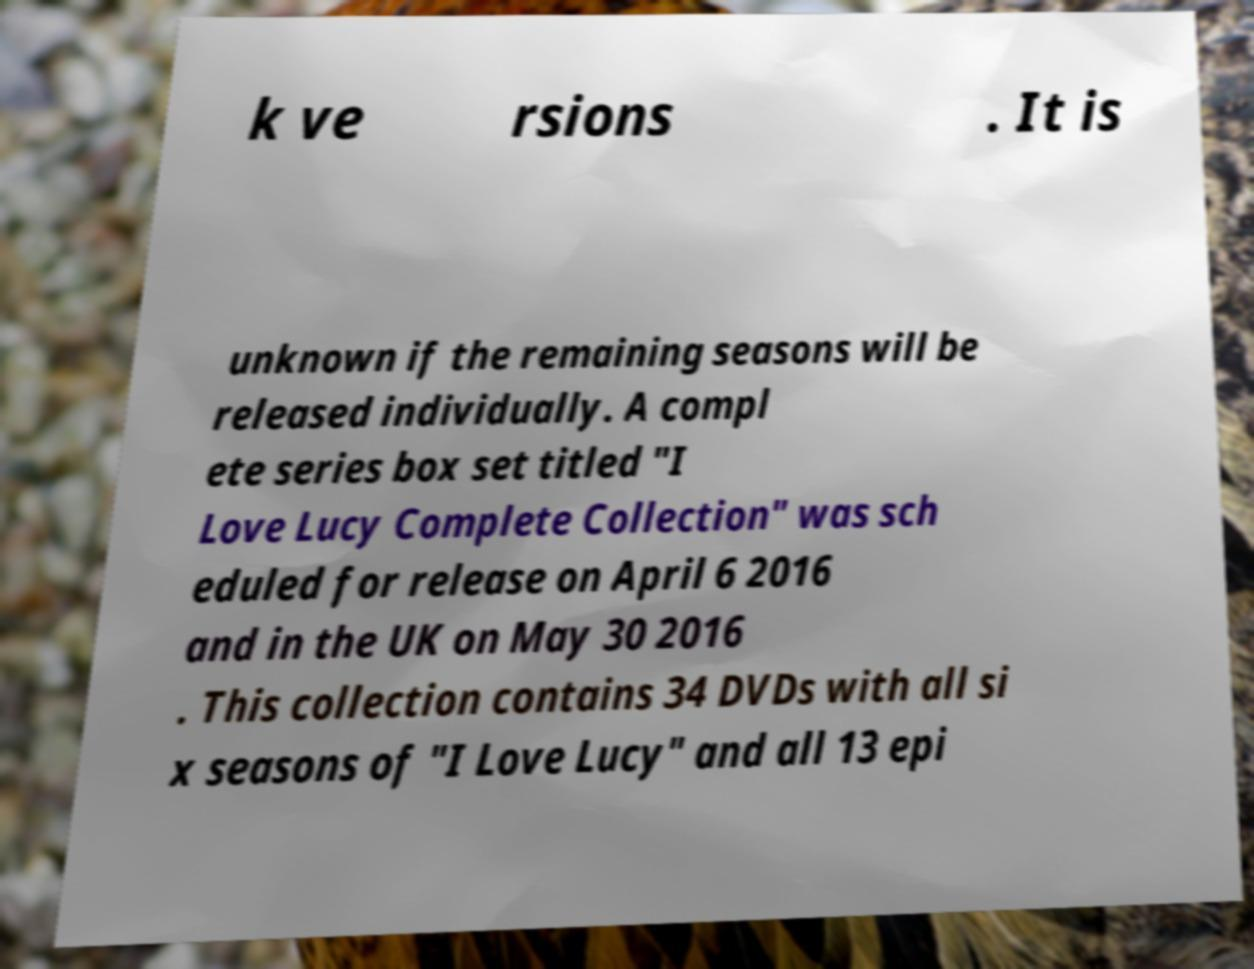Can you accurately transcribe the text from the provided image for me? k ve rsions . It is unknown if the remaining seasons will be released individually. A compl ete series box set titled "I Love Lucy Complete Collection" was sch eduled for release on April 6 2016 and in the UK on May 30 2016 . This collection contains 34 DVDs with all si x seasons of "I Love Lucy" and all 13 epi 